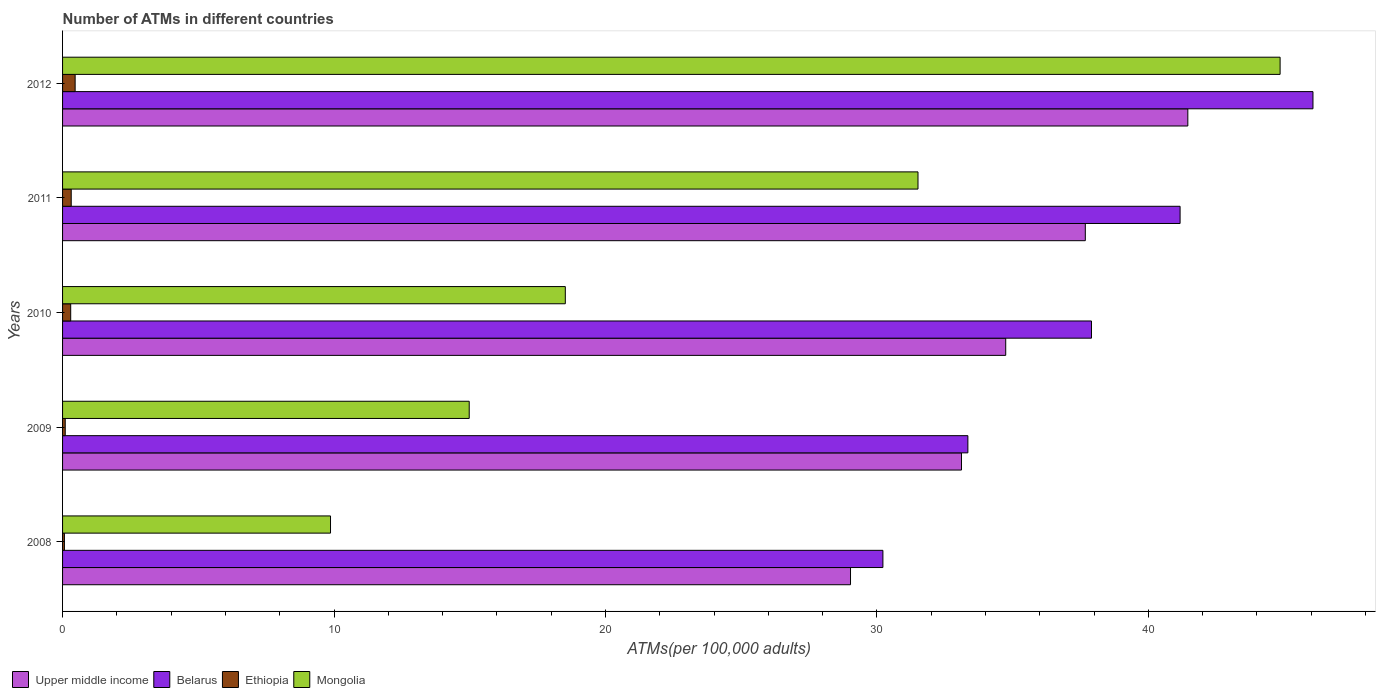How many different coloured bars are there?
Offer a very short reply. 4. How many groups of bars are there?
Make the answer very short. 5. Are the number of bars per tick equal to the number of legend labels?
Provide a succinct answer. Yes. Are the number of bars on each tick of the Y-axis equal?
Keep it short and to the point. Yes. How many bars are there on the 1st tick from the top?
Keep it short and to the point. 4. How many bars are there on the 3rd tick from the bottom?
Your answer should be very brief. 4. What is the label of the 2nd group of bars from the top?
Give a very brief answer. 2011. In how many cases, is the number of bars for a given year not equal to the number of legend labels?
Your answer should be very brief. 0. What is the number of ATMs in Mongolia in 2011?
Ensure brevity in your answer.  31.51. Across all years, what is the maximum number of ATMs in Mongolia?
Keep it short and to the point. 44.85. Across all years, what is the minimum number of ATMs in Ethiopia?
Your answer should be compact. 0.07. In which year was the number of ATMs in Upper middle income maximum?
Your response must be concise. 2012. What is the total number of ATMs in Ethiopia in the graph?
Ensure brevity in your answer.  1.25. What is the difference between the number of ATMs in Belarus in 2009 and that in 2011?
Your answer should be compact. -7.82. What is the difference between the number of ATMs in Mongolia in 2008 and the number of ATMs in Belarus in 2012?
Make the answer very short. -36.19. What is the average number of ATMs in Ethiopia per year?
Provide a short and direct response. 0.25. In the year 2010, what is the difference between the number of ATMs in Mongolia and number of ATMs in Ethiopia?
Make the answer very short. 18.22. In how many years, is the number of ATMs in Upper middle income greater than 24 ?
Provide a short and direct response. 5. What is the ratio of the number of ATMs in Mongolia in 2008 to that in 2011?
Keep it short and to the point. 0.31. Is the number of ATMs in Upper middle income in 2008 less than that in 2010?
Give a very brief answer. Yes. Is the difference between the number of ATMs in Mongolia in 2009 and 2012 greater than the difference between the number of ATMs in Ethiopia in 2009 and 2012?
Give a very brief answer. No. What is the difference between the highest and the second highest number of ATMs in Belarus?
Provide a short and direct response. 4.9. What is the difference between the highest and the lowest number of ATMs in Ethiopia?
Keep it short and to the point. 0.39. In how many years, is the number of ATMs in Mongolia greater than the average number of ATMs in Mongolia taken over all years?
Offer a terse response. 2. What does the 2nd bar from the top in 2010 represents?
Your answer should be very brief. Ethiopia. What does the 2nd bar from the bottom in 2011 represents?
Make the answer very short. Belarus. Is it the case that in every year, the sum of the number of ATMs in Mongolia and number of ATMs in Belarus is greater than the number of ATMs in Upper middle income?
Provide a short and direct response. Yes. How many bars are there?
Give a very brief answer. 20. How many years are there in the graph?
Make the answer very short. 5. Does the graph contain grids?
Make the answer very short. No. Where does the legend appear in the graph?
Provide a short and direct response. Bottom left. What is the title of the graph?
Your response must be concise. Number of ATMs in different countries. What is the label or title of the X-axis?
Make the answer very short. ATMs(per 100,0 adults). What is the label or title of the Y-axis?
Provide a short and direct response. Years. What is the ATMs(per 100,000 adults) of Upper middle income in 2008?
Your answer should be very brief. 29.03. What is the ATMs(per 100,000 adults) of Belarus in 2008?
Keep it short and to the point. 30.22. What is the ATMs(per 100,000 adults) of Ethiopia in 2008?
Your response must be concise. 0.07. What is the ATMs(per 100,000 adults) in Mongolia in 2008?
Make the answer very short. 9.87. What is the ATMs(per 100,000 adults) of Upper middle income in 2009?
Provide a short and direct response. 33.12. What is the ATMs(per 100,000 adults) in Belarus in 2009?
Provide a succinct answer. 33.35. What is the ATMs(per 100,000 adults) in Ethiopia in 2009?
Your answer should be very brief. 0.1. What is the ATMs(per 100,000 adults) of Mongolia in 2009?
Make the answer very short. 14.98. What is the ATMs(per 100,000 adults) of Upper middle income in 2010?
Keep it short and to the point. 34.74. What is the ATMs(per 100,000 adults) in Belarus in 2010?
Keep it short and to the point. 37.9. What is the ATMs(per 100,000 adults) of Ethiopia in 2010?
Keep it short and to the point. 0.3. What is the ATMs(per 100,000 adults) of Mongolia in 2010?
Offer a very short reply. 18.52. What is the ATMs(per 100,000 adults) of Upper middle income in 2011?
Provide a short and direct response. 37.68. What is the ATMs(per 100,000 adults) in Belarus in 2011?
Your answer should be compact. 41.17. What is the ATMs(per 100,000 adults) in Ethiopia in 2011?
Ensure brevity in your answer.  0.32. What is the ATMs(per 100,000 adults) in Mongolia in 2011?
Give a very brief answer. 31.51. What is the ATMs(per 100,000 adults) in Upper middle income in 2012?
Make the answer very short. 41.45. What is the ATMs(per 100,000 adults) in Belarus in 2012?
Provide a short and direct response. 46.06. What is the ATMs(per 100,000 adults) of Ethiopia in 2012?
Your response must be concise. 0.46. What is the ATMs(per 100,000 adults) in Mongolia in 2012?
Keep it short and to the point. 44.85. Across all years, what is the maximum ATMs(per 100,000 adults) of Upper middle income?
Ensure brevity in your answer.  41.45. Across all years, what is the maximum ATMs(per 100,000 adults) of Belarus?
Your response must be concise. 46.06. Across all years, what is the maximum ATMs(per 100,000 adults) in Ethiopia?
Your answer should be compact. 0.46. Across all years, what is the maximum ATMs(per 100,000 adults) in Mongolia?
Make the answer very short. 44.85. Across all years, what is the minimum ATMs(per 100,000 adults) in Upper middle income?
Give a very brief answer. 29.03. Across all years, what is the minimum ATMs(per 100,000 adults) of Belarus?
Offer a very short reply. 30.22. Across all years, what is the minimum ATMs(per 100,000 adults) in Ethiopia?
Make the answer very short. 0.07. Across all years, what is the minimum ATMs(per 100,000 adults) of Mongolia?
Offer a terse response. 9.87. What is the total ATMs(per 100,000 adults) of Upper middle income in the graph?
Provide a succinct answer. 176.02. What is the total ATMs(per 100,000 adults) of Belarus in the graph?
Ensure brevity in your answer.  188.71. What is the total ATMs(per 100,000 adults) of Ethiopia in the graph?
Offer a terse response. 1.25. What is the total ATMs(per 100,000 adults) in Mongolia in the graph?
Give a very brief answer. 119.74. What is the difference between the ATMs(per 100,000 adults) in Upper middle income in 2008 and that in 2009?
Your answer should be compact. -4.09. What is the difference between the ATMs(per 100,000 adults) of Belarus in 2008 and that in 2009?
Offer a very short reply. -3.13. What is the difference between the ATMs(per 100,000 adults) of Ethiopia in 2008 and that in 2009?
Offer a terse response. -0.03. What is the difference between the ATMs(per 100,000 adults) of Mongolia in 2008 and that in 2009?
Your answer should be very brief. -5.11. What is the difference between the ATMs(per 100,000 adults) of Upper middle income in 2008 and that in 2010?
Provide a succinct answer. -5.72. What is the difference between the ATMs(per 100,000 adults) of Belarus in 2008 and that in 2010?
Your answer should be compact. -7.68. What is the difference between the ATMs(per 100,000 adults) in Ethiopia in 2008 and that in 2010?
Your answer should be compact. -0.23. What is the difference between the ATMs(per 100,000 adults) in Mongolia in 2008 and that in 2010?
Your answer should be compact. -8.65. What is the difference between the ATMs(per 100,000 adults) in Upper middle income in 2008 and that in 2011?
Your answer should be very brief. -8.65. What is the difference between the ATMs(per 100,000 adults) in Belarus in 2008 and that in 2011?
Provide a succinct answer. -10.95. What is the difference between the ATMs(per 100,000 adults) in Ethiopia in 2008 and that in 2011?
Give a very brief answer. -0.25. What is the difference between the ATMs(per 100,000 adults) of Mongolia in 2008 and that in 2011?
Offer a very short reply. -21.64. What is the difference between the ATMs(per 100,000 adults) of Upper middle income in 2008 and that in 2012?
Ensure brevity in your answer.  -12.43. What is the difference between the ATMs(per 100,000 adults) of Belarus in 2008 and that in 2012?
Give a very brief answer. -15.84. What is the difference between the ATMs(per 100,000 adults) in Ethiopia in 2008 and that in 2012?
Keep it short and to the point. -0.39. What is the difference between the ATMs(per 100,000 adults) of Mongolia in 2008 and that in 2012?
Offer a very short reply. -34.98. What is the difference between the ATMs(per 100,000 adults) in Upper middle income in 2009 and that in 2010?
Your response must be concise. -1.63. What is the difference between the ATMs(per 100,000 adults) in Belarus in 2009 and that in 2010?
Give a very brief answer. -4.55. What is the difference between the ATMs(per 100,000 adults) of Ethiopia in 2009 and that in 2010?
Keep it short and to the point. -0.2. What is the difference between the ATMs(per 100,000 adults) of Mongolia in 2009 and that in 2010?
Provide a short and direct response. -3.54. What is the difference between the ATMs(per 100,000 adults) in Upper middle income in 2009 and that in 2011?
Provide a short and direct response. -4.56. What is the difference between the ATMs(per 100,000 adults) of Belarus in 2009 and that in 2011?
Keep it short and to the point. -7.82. What is the difference between the ATMs(per 100,000 adults) in Ethiopia in 2009 and that in 2011?
Offer a very short reply. -0.22. What is the difference between the ATMs(per 100,000 adults) in Mongolia in 2009 and that in 2011?
Offer a very short reply. -16.53. What is the difference between the ATMs(per 100,000 adults) in Upper middle income in 2009 and that in 2012?
Provide a succinct answer. -8.34. What is the difference between the ATMs(per 100,000 adults) in Belarus in 2009 and that in 2012?
Keep it short and to the point. -12.71. What is the difference between the ATMs(per 100,000 adults) in Ethiopia in 2009 and that in 2012?
Offer a terse response. -0.36. What is the difference between the ATMs(per 100,000 adults) in Mongolia in 2009 and that in 2012?
Your answer should be compact. -29.87. What is the difference between the ATMs(per 100,000 adults) in Upper middle income in 2010 and that in 2011?
Ensure brevity in your answer.  -2.93. What is the difference between the ATMs(per 100,000 adults) of Belarus in 2010 and that in 2011?
Make the answer very short. -3.26. What is the difference between the ATMs(per 100,000 adults) in Ethiopia in 2010 and that in 2011?
Give a very brief answer. -0.02. What is the difference between the ATMs(per 100,000 adults) in Mongolia in 2010 and that in 2011?
Ensure brevity in your answer.  -12.99. What is the difference between the ATMs(per 100,000 adults) of Upper middle income in 2010 and that in 2012?
Your response must be concise. -6.71. What is the difference between the ATMs(per 100,000 adults) in Belarus in 2010 and that in 2012?
Provide a succinct answer. -8.16. What is the difference between the ATMs(per 100,000 adults) in Ethiopia in 2010 and that in 2012?
Ensure brevity in your answer.  -0.16. What is the difference between the ATMs(per 100,000 adults) of Mongolia in 2010 and that in 2012?
Provide a succinct answer. -26.33. What is the difference between the ATMs(per 100,000 adults) of Upper middle income in 2011 and that in 2012?
Make the answer very short. -3.78. What is the difference between the ATMs(per 100,000 adults) of Belarus in 2011 and that in 2012?
Your answer should be very brief. -4.9. What is the difference between the ATMs(per 100,000 adults) of Ethiopia in 2011 and that in 2012?
Ensure brevity in your answer.  -0.14. What is the difference between the ATMs(per 100,000 adults) of Mongolia in 2011 and that in 2012?
Offer a very short reply. -13.34. What is the difference between the ATMs(per 100,000 adults) of Upper middle income in 2008 and the ATMs(per 100,000 adults) of Belarus in 2009?
Your response must be concise. -4.32. What is the difference between the ATMs(per 100,000 adults) of Upper middle income in 2008 and the ATMs(per 100,000 adults) of Ethiopia in 2009?
Give a very brief answer. 28.93. What is the difference between the ATMs(per 100,000 adults) in Upper middle income in 2008 and the ATMs(per 100,000 adults) in Mongolia in 2009?
Your answer should be compact. 14.05. What is the difference between the ATMs(per 100,000 adults) in Belarus in 2008 and the ATMs(per 100,000 adults) in Ethiopia in 2009?
Make the answer very short. 30.12. What is the difference between the ATMs(per 100,000 adults) in Belarus in 2008 and the ATMs(per 100,000 adults) in Mongolia in 2009?
Give a very brief answer. 15.24. What is the difference between the ATMs(per 100,000 adults) in Ethiopia in 2008 and the ATMs(per 100,000 adults) in Mongolia in 2009?
Provide a short and direct response. -14.91. What is the difference between the ATMs(per 100,000 adults) of Upper middle income in 2008 and the ATMs(per 100,000 adults) of Belarus in 2010?
Make the answer very short. -8.88. What is the difference between the ATMs(per 100,000 adults) in Upper middle income in 2008 and the ATMs(per 100,000 adults) in Ethiopia in 2010?
Offer a very short reply. 28.73. What is the difference between the ATMs(per 100,000 adults) in Upper middle income in 2008 and the ATMs(per 100,000 adults) in Mongolia in 2010?
Your response must be concise. 10.51. What is the difference between the ATMs(per 100,000 adults) in Belarus in 2008 and the ATMs(per 100,000 adults) in Ethiopia in 2010?
Offer a very short reply. 29.92. What is the difference between the ATMs(per 100,000 adults) of Belarus in 2008 and the ATMs(per 100,000 adults) of Mongolia in 2010?
Make the answer very short. 11.7. What is the difference between the ATMs(per 100,000 adults) of Ethiopia in 2008 and the ATMs(per 100,000 adults) of Mongolia in 2010?
Your answer should be very brief. -18.45. What is the difference between the ATMs(per 100,000 adults) of Upper middle income in 2008 and the ATMs(per 100,000 adults) of Belarus in 2011?
Give a very brief answer. -12.14. What is the difference between the ATMs(per 100,000 adults) in Upper middle income in 2008 and the ATMs(per 100,000 adults) in Ethiopia in 2011?
Offer a very short reply. 28.71. What is the difference between the ATMs(per 100,000 adults) in Upper middle income in 2008 and the ATMs(per 100,000 adults) in Mongolia in 2011?
Give a very brief answer. -2.49. What is the difference between the ATMs(per 100,000 adults) in Belarus in 2008 and the ATMs(per 100,000 adults) in Ethiopia in 2011?
Provide a short and direct response. 29.9. What is the difference between the ATMs(per 100,000 adults) in Belarus in 2008 and the ATMs(per 100,000 adults) in Mongolia in 2011?
Provide a short and direct response. -1.29. What is the difference between the ATMs(per 100,000 adults) of Ethiopia in 2008 and the ATMs(per 100,000 adults) of Mongolia in 2011?
Your answer should be compact. -31.44. What is the difference between the ATMs(per 100,000 adults) of Upper middle income in 2008 and the ATMs(per 100,000 adults) of Belarus in 2012?
Your response must be concise. -17.04. What is the difference between the ATMs(per 100,000 adults) in Upper middle income in 2008 and the ATMs(per 100,000 adults) in Ethiopia in 2012?
Your answer should be very brief. 28.56. What is the difference between the ATMs(per 100,000 adults) in Upper middle income in 2008 and the ATMs(per 100,000 adults) in Mongolia in 2012?
Make the answer very short. -15.83. What is the difference between the ATMs(per 100,000 adults) of Belarus in 2008 and the ATMs(per 100,000 adults) of Ethiopia in 2012?
Your answer should be very brief. 29.76. What is the difference between the ATMs(per 100,000 adults) of Belarus in 2008 and the ATMs(per 100,000 adults) of Mongolia in 2012?
Your answer should be very brief. -14.63. What is the difference between the ATMs(per 100,000 adults) of Ethiopia in 2008 and the ATMs(per 100,000 adults) of Mongolia in 2012?
Make the answer very short. -44.78. What is the difference between the ATMs(per 100,000 adults) of Upper middle income in 2009 and the ATMs(per 100,000 adults) of Belarus in 2010?
Your answer should be very brief. -4.79. What is the difference between the ATMs(per 100,000 adults) in Upper middle income in 2009 and the ATMs(per 100,000 adults) in Ethiopia in 2010?
Keep it short and to the point. 32.82. What is the difference between the ATMs(per 100,000 adults) of Upper middle income in 2009 and the ATMs(per 100,000 adults) of Mongolia in 2010?
Keep it short and to the point. 14.59. What is the difference between the ATMs(per 100,000 adults) in Belarus in 2009 and the ATMs(per 100,000 adults) in Ethiopia in 2010?
Ensure brevity in your answer.  33.05. What is the difference between the ATMs(per 100,000 adults) in Belarus in 2009 and the ATMs(per 100,000 adults) in Mongolia in 2010?
Provide a succinct answer. 14.83. What is the difference between the ATMs(per 100,000 adults) of Ethiopia in 2009 and the ATMs(per 100,000 adults) of Mongolia in 2010?
Provide a succinct answer. -18.42. What is the difference between the ATMs(per 100,000 adults) of Upper middle income in 2009 and the ATMs(per 100,000 adults) of Belarus in 2011?
Provide a succinct answer. -8.05. What is the difference between the ATMs(per 100,000 adults) in Upper middle income in 2009 and the ATMs(per 100,000 adults) in Ethiopia in 2011?
Offer a terse response. 32.8. What is the difference between the ATMs(per 100,000 adults) in Upper middle income in 2009 and the ATMs(per 100,000 adults) in Mongolia in 2011?
Your answer should be very brief. 1.6. What is the difference between the ATMs(per 100,000 adults) of Belarus in 2009 and the ATMs(per 100,000 adults) of Ethiopia in 2011?
Offer a very short reply. 33.03. What is the difference between the ATMs(per 100,000 adults) in Belarus in 2009 and the ATMs(per 100,000 adults) in Mongolia in 2011?
Make the answer very short. 1.84. What is the difference between the ATMs(per 100,000 adults) in Ethiopia in 2009 and the ATMs(per 100,000 adults) in Mongolia in 2011?
Provide a succinct answer. -31.41. What is the difference between the ATMs(per 100,000 adults) in Upper middle income in 2009 and the ATMs(per 100,000 adults) in Belarus in 2012?
Give a very brief answer. -12.95. What is the difference between the ATMs(per 100,000 adults) in Upper middle income in 2009 and the ATMs(per 100,000 adults) in Ethiopia in 2012?
Provide a succinct answer. 32.65. What is the difference between the ATMs(per 100,000 adults) in Upper middle income in 2009 and the ATMs(per 100,000 adults) in Mongolia in 2012?
Make the answer very short. -11.74. What is the difference between the ATMs(per 100,000 adults) of Belarus in 2009 and the ATMs(per 100,000 adults) of Ethiopia in 2012?
Your response must be concise. 32.89. What is the difference between the ATMs(per 100,000 adults) of Belarus in 2009 and the ATMs(per 100,000 adults) of Mongolia in 2012?
Your answer should be very brief. -11.5. What is the difference between the ATMs(per 100,000 adults) of Ethiopia in 2009 and the ATMs(per 100,000 adults) of Mongolia in 2012?
Your answer should be very brief. -44.75. What is the difference between the ATMs(per 100,000 adults) in Upper middle income in 2010 and the ATMs(per 100,000 adults) in Belarus in 2011?
Offer a very short reply. -6.42. What is the difference between the ATMs(per 100,000 adults) of Upper middle income in 2010 and the ATMs(per 100,000 adults) of Ethiopia in 2011?
Your answer should be compact. 34.43. What is the difference between the ATMs(per 100,000 adults) of Upper middle income in 2010 and the ATMs(per 100,000 adults) of Mongolia in 2011?
Your answer should be compact. 3.23. What is the difference between the ATMs(per 100,000 adults) of Belarus in 2010 and the ATMs(per 100,000 adults) of Ethiopia in 2011?
Your answer should be compact. 37.59. What is the difference between the ATMs(per 100,000 adults) in Belarus in 2010 and the ATMs(per 100,000 adults) in Mongolia in 2011?
Give a very brief answer. 6.39. What is the difference between the ATMs(per 100,000 adults) in Ethiopia in 2010 and the ATMs(per 100,000 adults) in Mongolia in 2011?
Offer a very short reply. -31.21. What is the difference between the ATMs(per 100,000 adults) of Upper middle income in 2010 and the ATMs(per 100,000 adults) of Belarus in 2012?
Offer a very short reply. -11.32. What is the difference between the ATMs(per 100,000 adults) of Upper middle income in 2010 and the ATMs(per 100,000 adults) of Ethiopia in 2012?
Your response must be concise. 34.28. What is the difference between the ATMs(per 100,000 adults) of Upper middle income in 2010 and the ATMs(per 100,000 adults) of Mongolia in 2012?
Provide a short and direct response. -10.11. What is the difference between the ATMs(per 100,000 adults) of Belarus in 2010 and the ATMs(per 100,000 adults) of Ethiopia in 2012?
Make the answer very short. 37.44. What is the difference between the ATMs(per 100,000 adults) of Belarus in 2010 and the ATMs(per 100,000 adults) of Mongolia in 2012?
Your answer should be compact. -6.95. What is the difference between the ATMs(per 100,000 adults) of Ethiopia in 2010 and the ATMs(per 100,000 adults) of Mongolia in 2012?
Your answer should be very brief. -44.55. What is the difference between the ATMs(per 100,000 adults) in Upper middle income in 2011 and the ATMs(per 100,000 adults) in Belarus in 2012?
Provide a short and direct response. -8.39. What is the difference between the ATMs(per 100,000 adults) in Upper middle income in 2011 and the ATMs(per 100,000 adults) in Ethiopia in 2012?
Keep it short and to the point. 37.21. What is the difference between the ATMs(per 100,000 adults) of Upper middle income in 2011 and the ATMs(per 100,000 adults) of Mongolia in 2012?
Give a very brief answer. -7.18. What is the difference between the ATMs(per 100,000 adults) of Belarus in 2011 and the ATMs(per 100,000 adults) of Ethiopia in 2012?
Make the answer very short. 40.71. What is the difference between the ATMs(per 100,000 adults) of Belarus in 2011 and the ATMs(per 100,000 adults) of Mongolia in 2012?
Ensure brevity in your answer.  -3.68. What is the difference between the ATMs(per 100,000 adults) in Ethiopia in 2011 and the ATMs(per 100,000 adults) in Mongolia in 2012?
Provide a succinct answer. -44.53. What is the average ATMs(per 100,000 adults) of Upper middle income per year?
Make the answer very short. 35.2. What is the average ATMs(per 100,000 adults) in Belarus per year?
Provide a short and direct response. 37.74. What is the average ATMs(per 100,000 adults) of Ethiopia per year?
Offer a terse response. 0.25. What is the average ATMs(per 100,000 adults) in Mongolia per year?
Make the answer very short. 23.95. In the year 2008, what is the difference between the ATMs(per 100,000 adults) of Upper middle income and ATMs(per 100,000 adults) of Belarus?
Keep it short and to the point. -1.19. In the year 2008, what is the difference between the ATMs(per 100,000 adults) in Upper middle income and ATMs(per 100,000 adults) in Ethiopia?
Give a very brief answer. 28.96. In the year 2008, what is the difference between the ATMs(per 100,000 adults) of Upper middle income and ATMs(per 100,000 adults) of Mongolia?
Keep it short and to the point. 19.16. In the year 2008, what is the difference between the ATMs(per 100,000 adults) in Belarus and ATMs(per 100,000 adults) in Ethiopia?
Provide a short and direct response. 30.15. In the year 2008, what is the difference between the ATMs(per 100,000 adults) in Belarus and ATMs(per 100,000 adults) in Mongolia?
Your answer should be very brief. 20.35. In the year 2008, what is the difference between the ATMs(per 100,000 adults) in Ethiopia and ATMs(per 100,000 adults) in Mongolia?
Your answer should be compact. -9.8. In the year 2009, what is the difference between the ATMs(per 100,000 adults) in Upper middle income and ATMs(per 100,000 adults) in Belarus?
Provide a short and direct response. -0.24. In the year 2009, what is the difference between the ATMs(per 100,000 adults) of Upper middle income and ATMs(per 100,000 adults) of Ethiopia?
Offer a terse response. 33.02. In the year 2009, what is the difference between the ATMs(per 100,000 adults) of Upper middle income and ATMs(per 100,000 adults) of Mongolia?
Ensure brevity in your answer.  18.13. In the year 2009, what is the difference between the ATMs(per 100,000 adults) of Belarus and ATMs(per 100,000 adults) of Ethiopia?
Your response must be concise. 33.25. In the year 2009, what is the difference between the ATMs(per 100,000 adults) of Belarus and ATMs(per 100,000 adults) of Mongolia?
Give a very brief answer. 18.37. In the year 2009, what is the difference between the ATMs(per 100,000 adults) of Ethiopia and ATMs(per 100,000 adults) of Mongolia?
Your answer should be compact. -14.88. In the year 2010, what is the difference between the ATMs(per 100,000 adults) in Upper middle income and ATMs(per 100,000 adults) in Belarus?
Your answer should be very brief. -3.16. In the year 2010, what is the difference between the ATMs(per 100,000 adults) of Upper middle income and ATMs(per 100,000 adults) of Ethiopia?
Give a very brief answer. 34.45. In the year 2010, what is the difference between the ATMs(per 100,000 adults) of Upper middle income and ATMs(per 100,000 adults) of Mongolia?
Give a very brief answer. 16.22. In the year 2010, what is the difference between the ATMs(per 100,000 adults) in Belarus and ATMs(per 100,000 adults) in Ethiopia?
Offer a very short reply. 37.6. In the year 2010, what is the difference between the ATMs(per 100,000 adults) in Belarus and ATMs(per 100,000 adults) in Mongolia?
Ensure brevity in your answer.  19.38. In the year 2010, what is the difference between the ATMs(per 100,000 adults) of Ethiopia and ATMs(per 100,000 adults) of Mongolia?
Provide a short and direct response. -18.22. In the year 2011, what is the difference between the ATMs(per 100,000 adults) of Upper middle income and ATMs(per 100,000 adults) of Belarus?
Give a very brief answer. -3.49. In the year 2011, what is the difference between the ATMs(per 100,000 adults) in Upper middle income and ATMs(per 100,000 adults) in Ethiopia?
Offer a very short reply. 37.36. In the year 2011, what is the difference between the ATMs(per 100,000 adults) of Upper middle income and ATMs(per 100,000 adults) of Mongolia?
Keep it short and to the point. 6.16. In the year 2011, what is the difference between the ATMs(per 100,000 adults) in Belarus and ATMs(per 100,000 adults) in Ethiopia?
Offer a very short reply. 40.85. In the year 2011, what is the difference between the ATMs(per 100,000 adults) of Belarus and ATMs(per 100,000 adults) of Mongolia?
Give a very brief answer. 9.66. In the year 2011, what is the difference between the ATMs(per 100,000 adults) of Ethiopia and ATMs(per 100,000 adults) of Mongolia?
Keep it short and to the point. -31.19. In the year 2012, what is the difference between the ATMs(per 100,000 adults) in Upper middle income and ATMs(per 100,000 adults) in Belarus?
Provide a short and direct response. -4.61. In the year 2012, what is the difference between the ATMs(per 100,000 adults) in Upper middle income and ATMs(per 100,000 adults) in Ethiopia?
Offer a very short reply. 40.99. In the year 2012, what is the difference between the ATMs(per 100,000 adults) of Upper middle income and ATMs(per 100,000 adults) of Mongolia?
Provide a short and direct response. -3.4. In the year 2012, what is the difference between the ATMs(per 100,000 adults) of Belarus and ATMs(per 100,000 adults) of Ethiopia?
Provide a short and direct response. 45.6. In the year 2012, what is the difference between the ATMs(per 100,000 adults) in Belarus and ATMs(per 100,000 adults) in Mongolia?
Offer a very short reply. 1.21. In the year 2012, what is the difference between the ATMs(per 100,000 adults) of Ethiopia and ATMs(per 100,000 adults) of Mongolia?
Keep it short and to the point. -44.39. What is the ratio of the ATMs(per 100,000 adults) in Upper middle income in 2008 to that in 2009?
Provide a short and direct response. 0.88. What is the ratio of the ATMs(per 100,000 adults) in Belarus in 2008 to that in 2009?
Keep it short and to the point. 0.91. What is the ratio of the ATMs(per 100,000 adults) in Ethiopia in 2008 to that in 2009?
Provide a succinct answer. 0.7. What is the ratio of the ATMs(per 100,000 adults) in Mongolia in 2008 to that in 2009?
Your answer should be very brief. 0.66. What is the ratio of the ATMs(per 100,000 adults) in Upper middle income in 2008 to that in 2010?
Your response must be concise. 0.84. What is the ratio of the ATMs(per 100,000 adults) in Belarus in 2008 to that in 2010?
Make the answer very short. 0.8. What is the ratio of the ATMs(per 100,000 adults) in Ethiopia in 2008 to that in 2010?
Offer a terse response. 0.23. What is the ratio of the ATMs(per 100,000 adults) in Mongolia in 2008 to that in 2010?
Offer a very short reply. 0.53. What is the ratio of the ATMs(per 100,000 adults) in Upper middle income in 2008 to that in 2011?
Offer a very short reply. 0.77. What is the ratio of the ATMs(per 100,000 adults) of Belarus in 2008 to that in 2011?
Keep it short and to the point. 0.73. What is the ratio of the ATMs(per 100,000 adults) in Ethiopia in 2008 to that in 2011?
Offer a very short reply. 0.22. What is the ratio of the ATMs(per 100,000 adults) of Mongolia in 2008 to that in 2011?
Provide a succinct answer. 0.31. What is the ratio of the ATMs(per 100,000 adults) in Upper middle income in 2008 to that in 2012?
Your answer should be compact. 0.7. What is the ratio of the ATMs(per 100,000 adults) in Belarus in 2008 to that in 2012?
Offer a terse response. 0.66. What is the ratio of the ATMs(per 100,000 adults) of Ethiopia in 2008 to that in 2012?
Keep it short and to the point. 0.15. What is the ratio of the ATMs(per 100,000 adults) of Mongolia in 2008 to that in 2012?
Make the answer very short. 0.22. What is the ratio of the ATMs(per 100,000 adults) in Upper middle income in 2009 to that in 2010?
Provide a short and direct response. 0.95. What is the ratio of the ATMs(per 100,000 adults) in Belarus in 2009 to that in 2010?
Your answer should be very brief. 0.88. What is the ratio of the ATMs(per 100,000 adults) in Ethiopia in 2009 to that in 2010?
Offer a very short reply. 0.33. What is the ratio of the ATMs(per 100,000 adults) in Mongolia in 2009 to that in 2010?
Make the answer very short. 0.81. What is the ratio of the ATMs(per 100,000 adults) of Upper middle income in 2009 to that in 2011?
Keep it short and to the point. 0.88. What is the ratio of the ATMs(per 100,000 adults) of Belarus in 2009 to that in 2011?
Ensure brevity in your answer.  0.81. What is the ratio of the ATMs(per 100,000 adults) of Ethiopia in 2009 to that in 2011?
Provide a succinct answer. 0.31. What is the ratio of the ATMs(per 100,000 adults) in Mongolia in 2009 to that in 2011?
Your response must be concise. 0.48. What is the ratio of the ATMs(per 100,000 adults) in Upper middle income in 2009 to that in 2012?
Offer a very short reply. 0.8. What is the ratio of the ATMs(per 100,000 adults) in Belarus in 2009 to that in 2012?
Provide a short and direct response. 0.72. What is the ratio of the ATMs(per 100,000 adults) of Ethiopia in 2009 to that in 2012?
Provide a short and direct response. 0.21. What is the ratio of the ATMs(per 100,000 adults) in Mongolia in 2009 to that in 2012?
Provide a succinct answer. 0.33. What is the ratio of the ATMs(per 100,000 adults) in Upper middle income in 2010 to that in 2011?
Offer a very short reply. 0.92. What is the ratio of the ATMs(per 100,000 adults) in Belarus in 2010 to that in 2011?
Keep it short and to the point. 0.92. What is the ratio of the ATMs(per 100,000 adults) in Ethiopia in 2010 to that in 2011?
Your response must be concise. 0.94. What is the ratio of the ATMs(per 100,000 adults) of Mongolia in 2010 to that in 2011?
Offer a terse response. 0.59. What is the ratio of the ATMs(per 100,000 adults) in Upper middle income in 2010 to that in 2012?
Your answer should be compact. 0.84. What is the ratio of the ATMs(per 100,000 adults) of Belarus in 2010 to that in 2012?
Provide a short and direct response. 0.82. What is the ratio of the ATMs(per 100,000 adults) of Ethiopia in 2010 to that in 2012?
Give a very brief answer. 0.65. What is the ratio of the ATMs(per 100,000 adults) of Mongolia in 2010 to that in 2012?
Your answer should be compact. 0.41. What is the ratio of the ATMs(per 100,000 adults) in Upper middle income in 2011 to that in 2012?
Your answer should be compact. 0.91. What is the ratio of the ATMs(per 100,000 adults) in Belarus in 2011 to that in 2012?
Offer a terse response. 0.89. What is the ratio of the ATMs(per 100,000 adults) of Ethiopia in 2011 to that in 2012?
Offer a terse response. 0.69. What is the ratio of the ATMs(per 100,000 adults) of Mongolia in 2011 to that in 2012?
Keep it short and to the point. 0.7. What is the difference between the highest and the second highest ATMs(per 100,000 adults) of Upper middle income?
Provide a succinct answer. 3.78. What is the difference between the highest and the second highest ATMs(per 100,000 adults) in Belarus?
Provide a short and direct response. 4.9. What is the difference between the highest and the second highest ATMs(per 100,000 adults) in Ethiopia?
Offer a very short reply. 0.14. What is the difference between the highest and the second highest ATMs(per 100,000 adults) in Mongolia?
Keep it short and to the point. 13.34. What is the difference between the highest and the lowest ATMs(per 100,000 adults) of Upper middle income?
Provide a succinct answer. 12.43. What is the difference between the highest and the lowest ATMs(per 100,000 adults) in Belarus?
Give a very brief answer. 15.84. What is the difference between the highest and the lowest ATMs(per 100,000 adults) in Ethiopia?
Your response must be concise. 0.39. What is the difference between the highest and the lowest ATMs(per 100,000 adults) in Mongolia?
Keep it short and to the point. 34.98. 